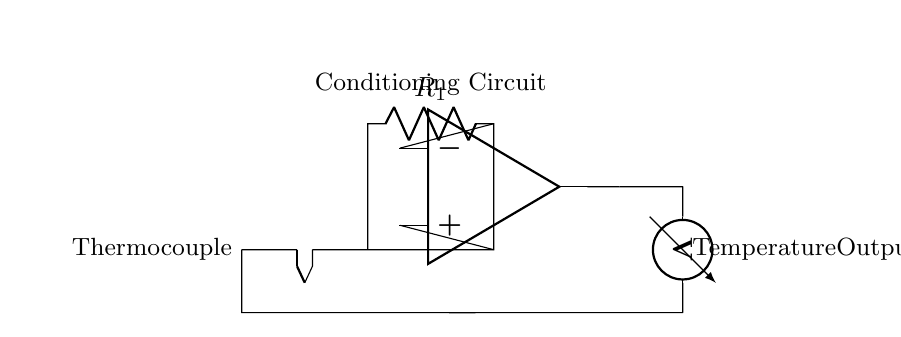What component is used to measure temperature? The component used to measure temperature is a thermocouple, as indicated in the circuit diagram. It converts temperature differences into voltage.
Answer: thermocouple What type of circuit is shown in the diagram? The circuit shown is an analog circuit, as it involves continuous signals for temperature monitoring. The thermocouple generates a voltage output proportional to temperature, and the op-amp amplifies this signal.
Answer: analog What is the role of the op-amp in this circuit? The op-amp acts as an amplifier to enhance the small voltage output from the thermocouple. It is crucial for increasing the signal strength to a measurable level at the output.
Answer: amplifier How many resistors are in the circuit? There is one resistor labeled R1 in the circuit diagram, which is part of the conditioning circuit for the thermocouple's output.
Answer: 1 What does the voltmeter measure in this circuit? The voltmeter measures the voltage output resulting from the temperature reading, providing a direct indication of the temperature based on the thermocouple’s output.
Answer: voltage What is provided at the output of the circuit? The output provides the measured temperature, indicated by the voltage output that has been amplified, which is essential for monitoring in book preservation rooms.
Answer: temperature output Why is the circuit specifically used for book preservation rooms? The circuit is designed for book preservation rooms to accurately monitor the temperature, as controlling the environment is crucial to prevent damage to sensitive materials, thus highlighting its application for historical document preservation.
Answer: environment control 